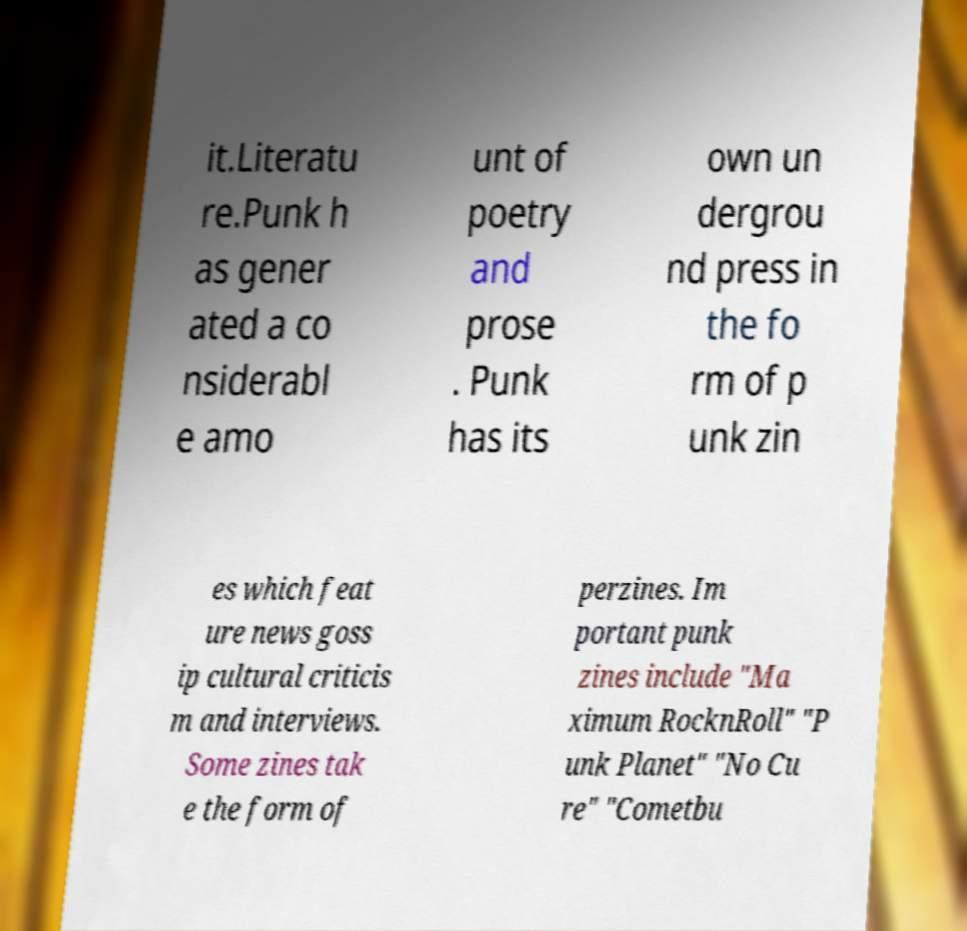Please identify and transcribe the text found in this image. it.Literatu re.Punk h as gener ated a co nsiderabl e amo unt of poetry and prose . Punk has its own un dergrou nd press in the fo rm of p unk zin es which feat ure news goss ip cultural criticis m and interviews. Some zines tak e the form of perzines. Im portant punk zines include "Ma ximum RocknRoll" "P unk Planet" "No Cu re" "Cometbu 